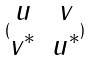Convert formula to latex. <formula><loc_0><loc_0><loc_500><loc_500>( \begin{matrix} u & v \\ v ^ { * } & u ^ { * } \end{matrix} )</formula> 